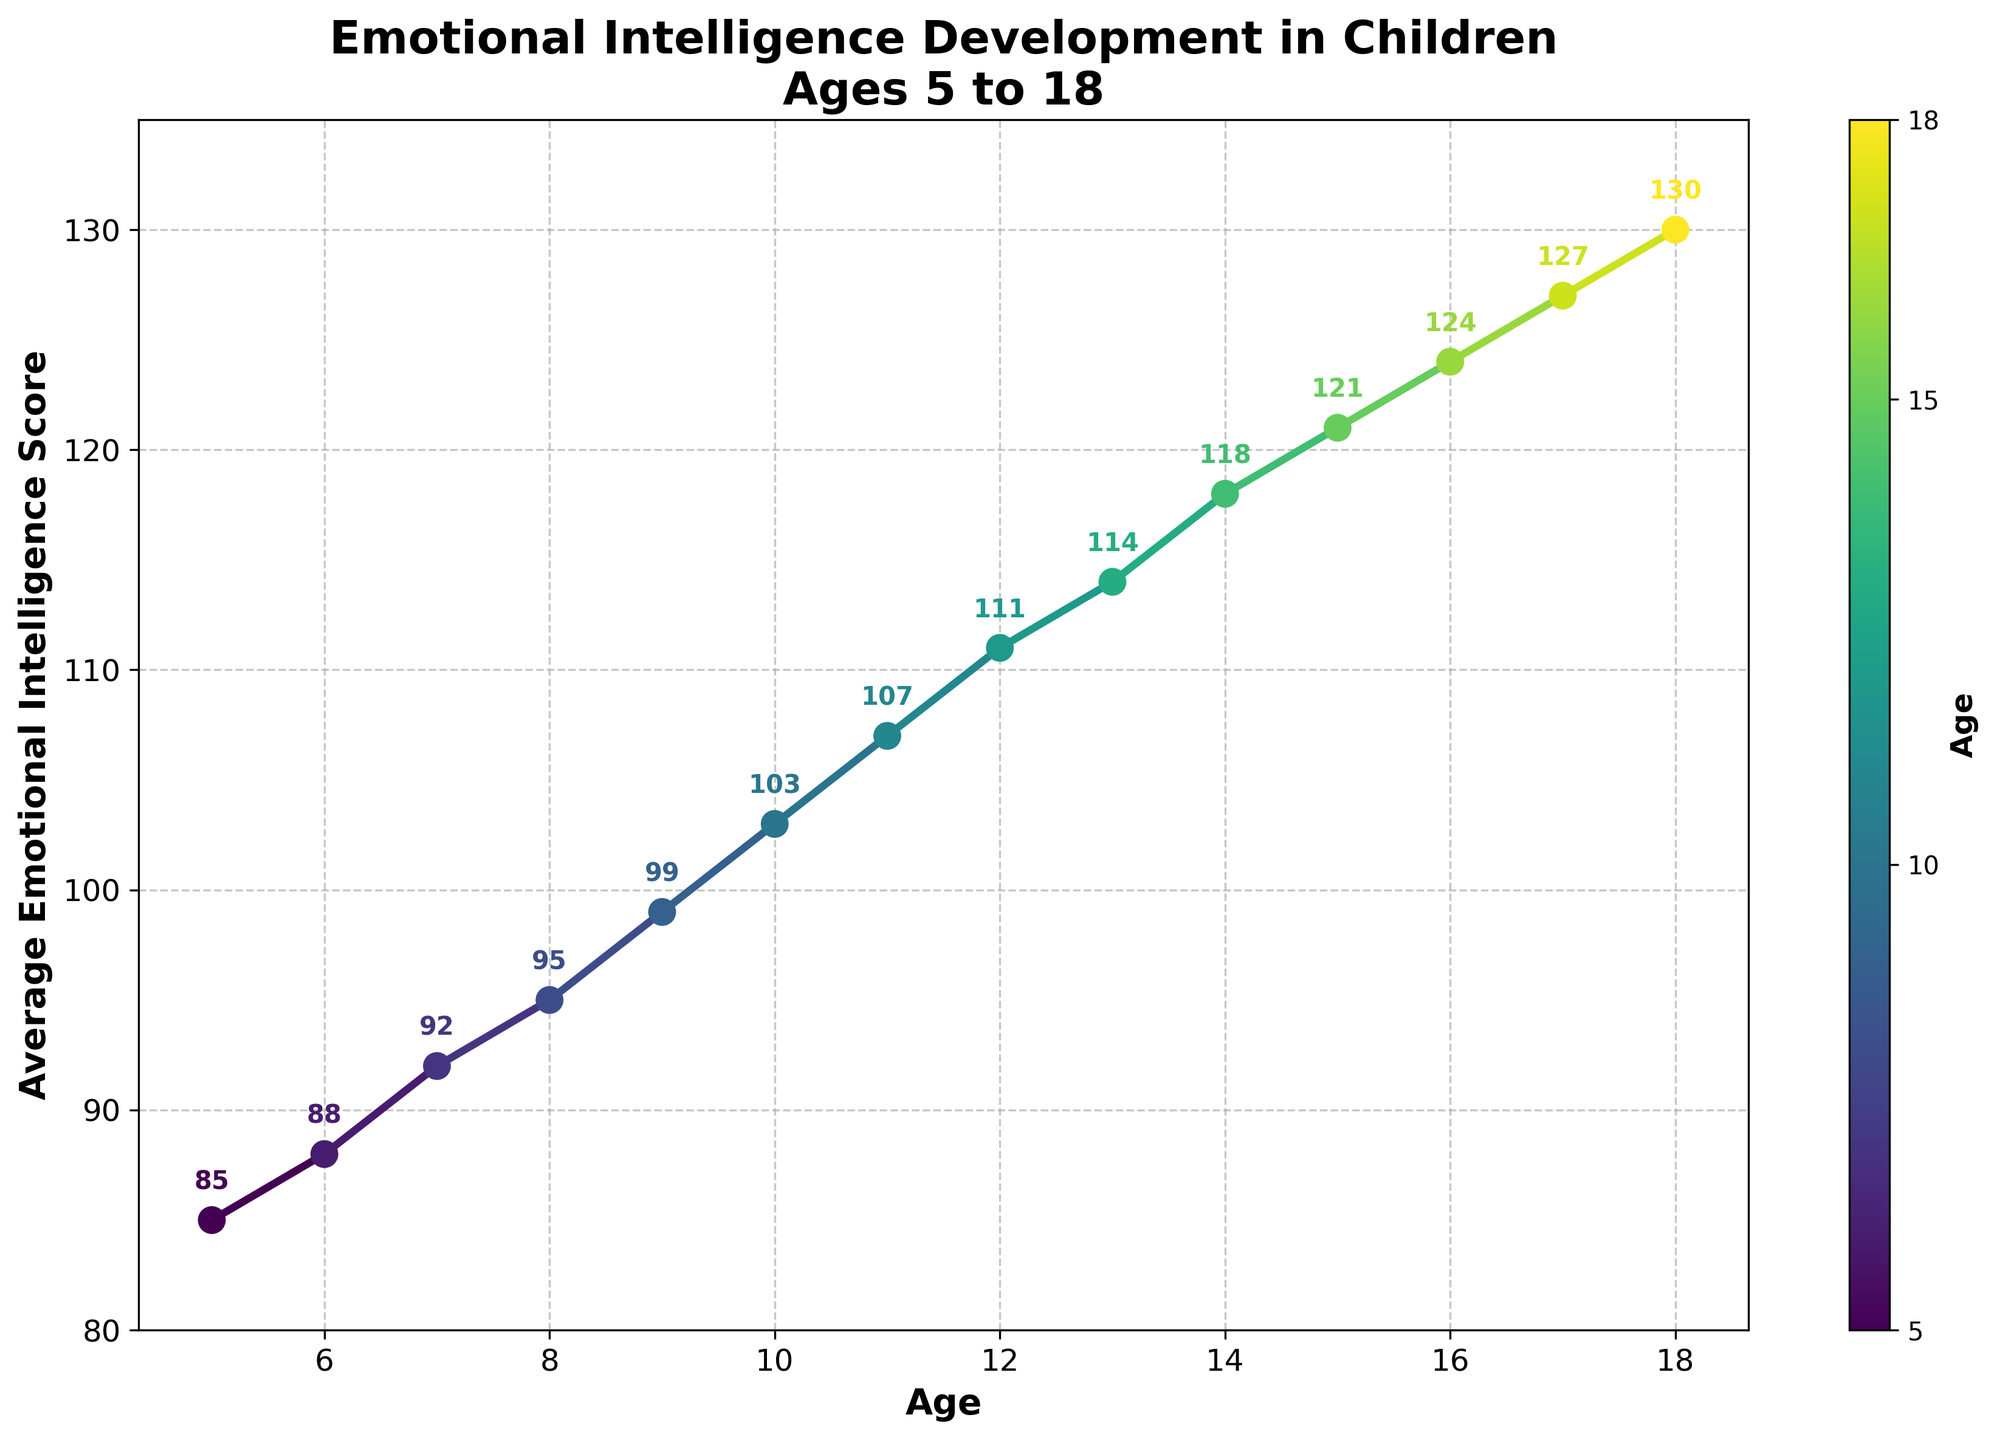What's the highest emotional intelligence score shown in the chart? The highest value can be observed by looking at the y-axis and identifying the point with the greatest y-value. The highest score is at age 18, with 130.
Answer: 130 Which age sees the first significant increase in the emotional intelligence score? A significant increase means a noticeable jump from one point to the next. Look at the consecutive data points on the y-axis. From age 5 to 6, there is a noticeable increase of 3 points (from 85 to 88).
Answer: 6 How do the emotional intelligence scores change between ages 10 and 12? To find this, look at the y-values corresponding to ages 10 and 12. The score at age 10 is 103, and the score at age 12 is 111. The difference is 111 - 103 = 8 points increase.
Answer: 8 Which age group shows the most rapid increase in emotional intelligence score? To identify this, calculate the differences between successive scores. The largest jump occurs between ages 8 (95) and 9 (99), which is a 4-point increase.
Answer: 8 to 9 Compare the scores at age 15 and age 16. Which is higher and by how much? Locate the scores for ages 15 and 16. Age 15 has a score of 121, and age 16 has a score of 124. The difference is 124 - 121 = 3 points, with age 16 having the higher score.
Answer: 16, by 3 points What is the average increase in emotional intelligence scores per year from age 5 to age 10? Calculate changes between each successive year from age 5 to 10 and find their average. The increases are (88-85), (92-88), (95-92), (99-95), (103-99). The total increase is 3 + 4 + 3 + 4 + 4 = 18. Average is 18 / 5 = 3.6.
Answer: 3.6 What color represents the age 12 on the chart? Identify the color gradient used to represent the ages. Based on the gradient color, age 12 should be analyzed. The color for age 12 falls somewhere between green and yellow.
Answer: Green-yellow mix Is the emotional intelligence score increase more rapid in early childhood (ages 5-10) or adolescence (ages 15-18)? Calculate the total increase for ages 5 to 10 and ages 15 to 18. Ages 5-10 has an increase of 18 points (103-85). Ages 15-18 has an increase of 9 points (130-121). Early childhood increase is more rapid.
Answer: Early childhood What's the trend in emotional intelligence scores from age 13 to age 18? Analyze the scores from age 13 to 18 (114, 118, 121, 124, 127, 130). The trend shows a consistent increase each year.
Answer: Consistent increase What is the score at age 9 and how does it compare with the score at age 14? Find the scores for ages 9 and 14 on the y-axis. Age 9 has a score of 99, and age 14 has a score of 118. Compare 118 - 99 = 19 points higher at age 14.
Answer: 118, 19 points higher 